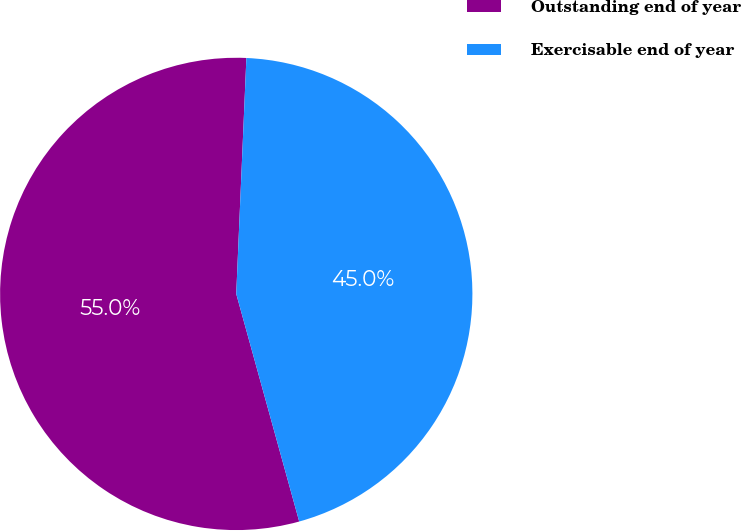Convert chart. <chart><loc_0><loc_0><loc_500><loc_500><pie_chart><fcel>Outstanding end of year<fcel>Exercisable end of year<nl><fcel>54.98%<fcel>45.02%<nl></chart> 